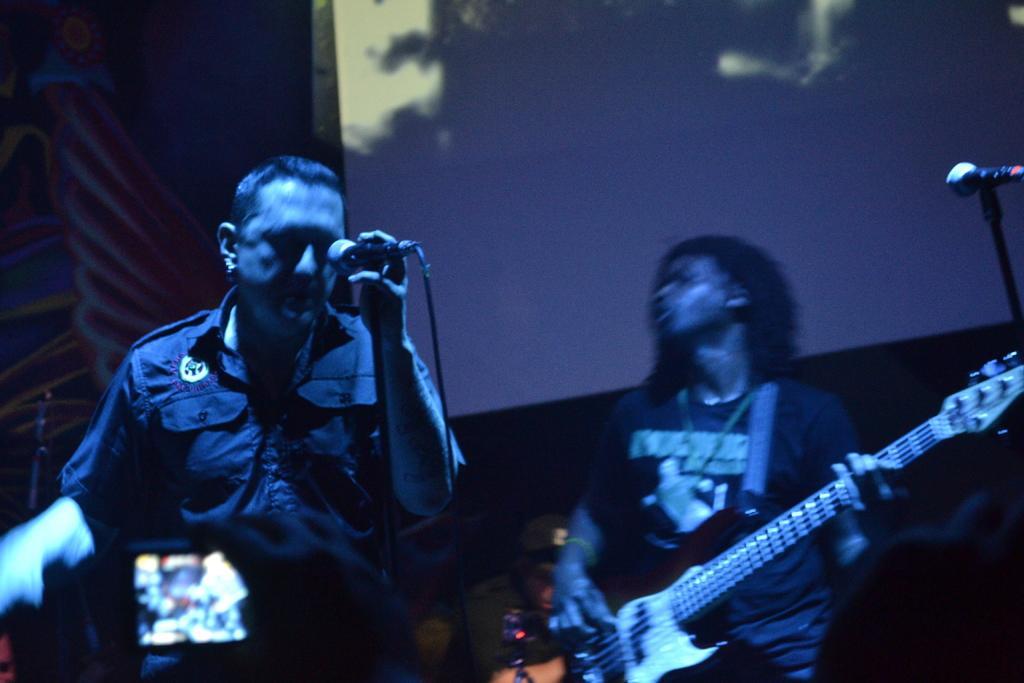In one or two sentences, can you explain what this image depicts? This persons are standing. This person is holding a mic. This person is holding a guitar. This is a screen. Mic with mic holder. 